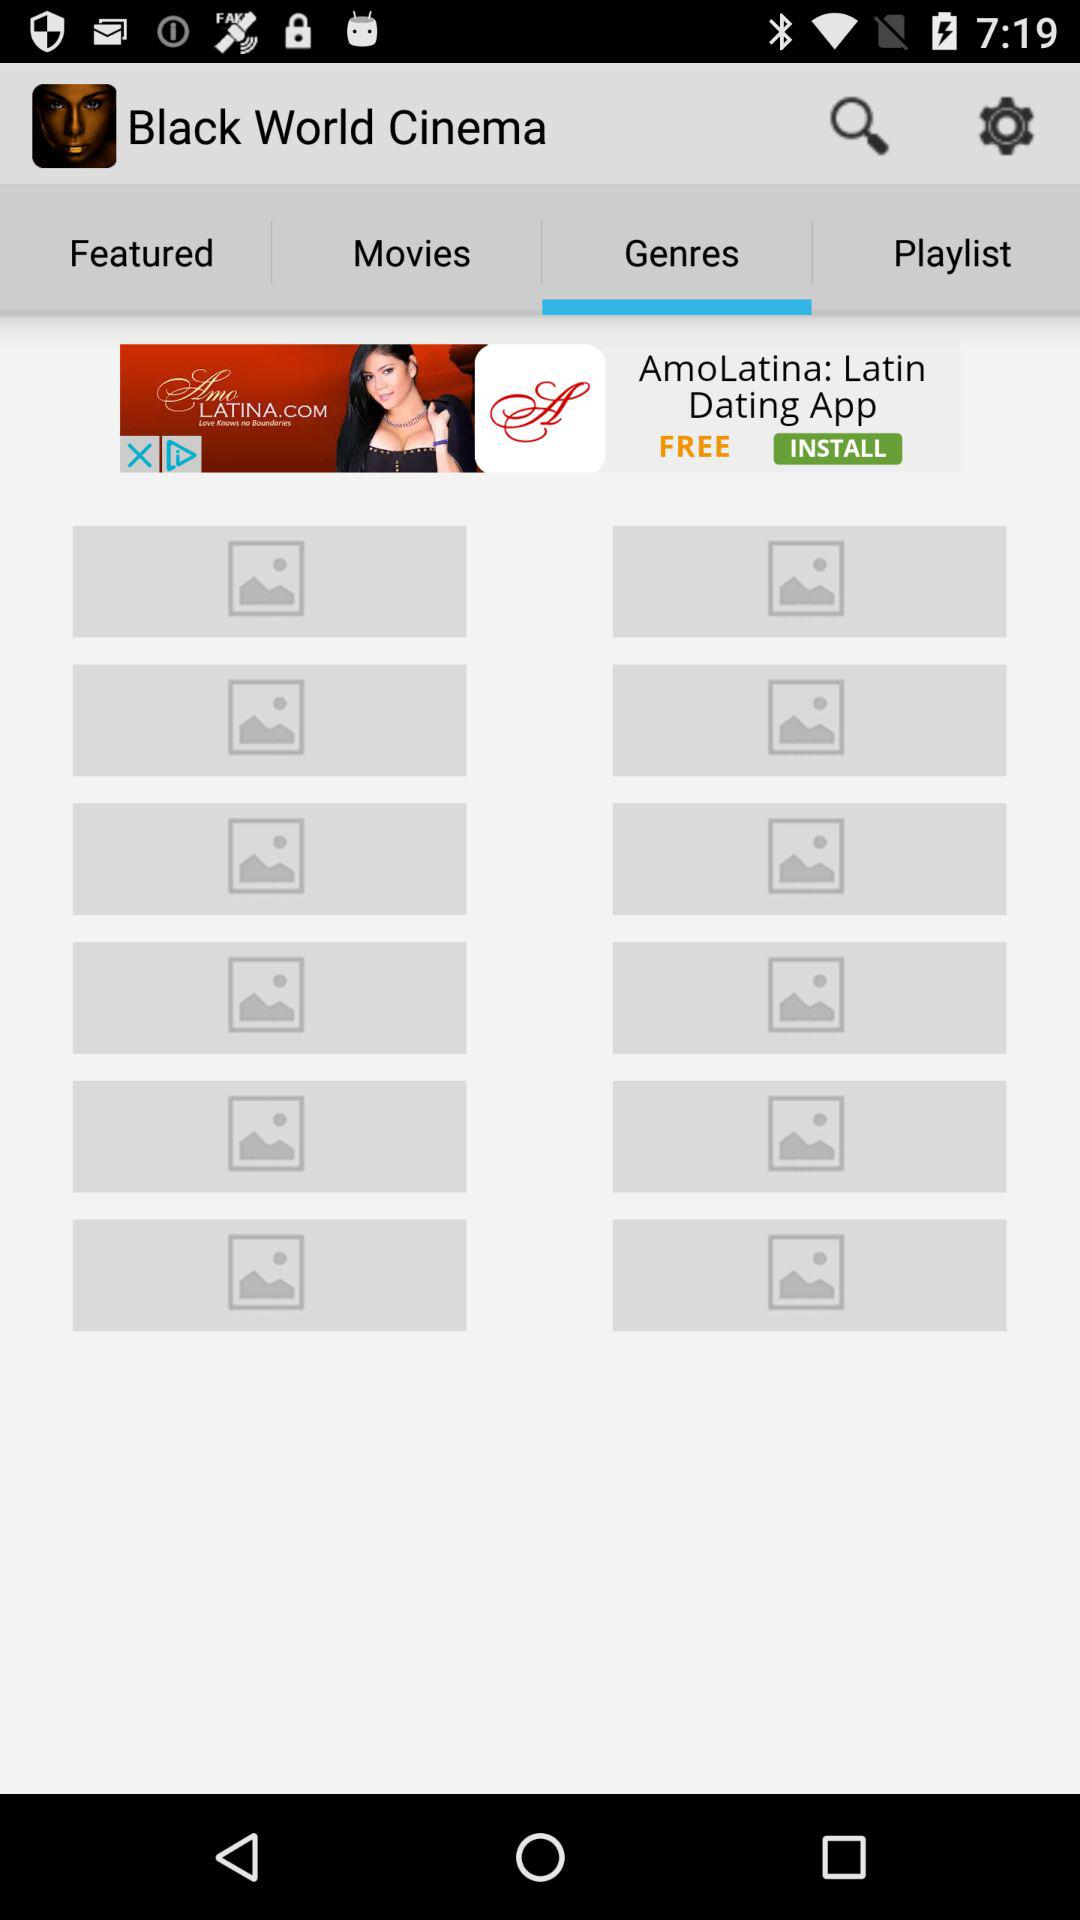What is the application name? The application name is "Black World Cinema". 